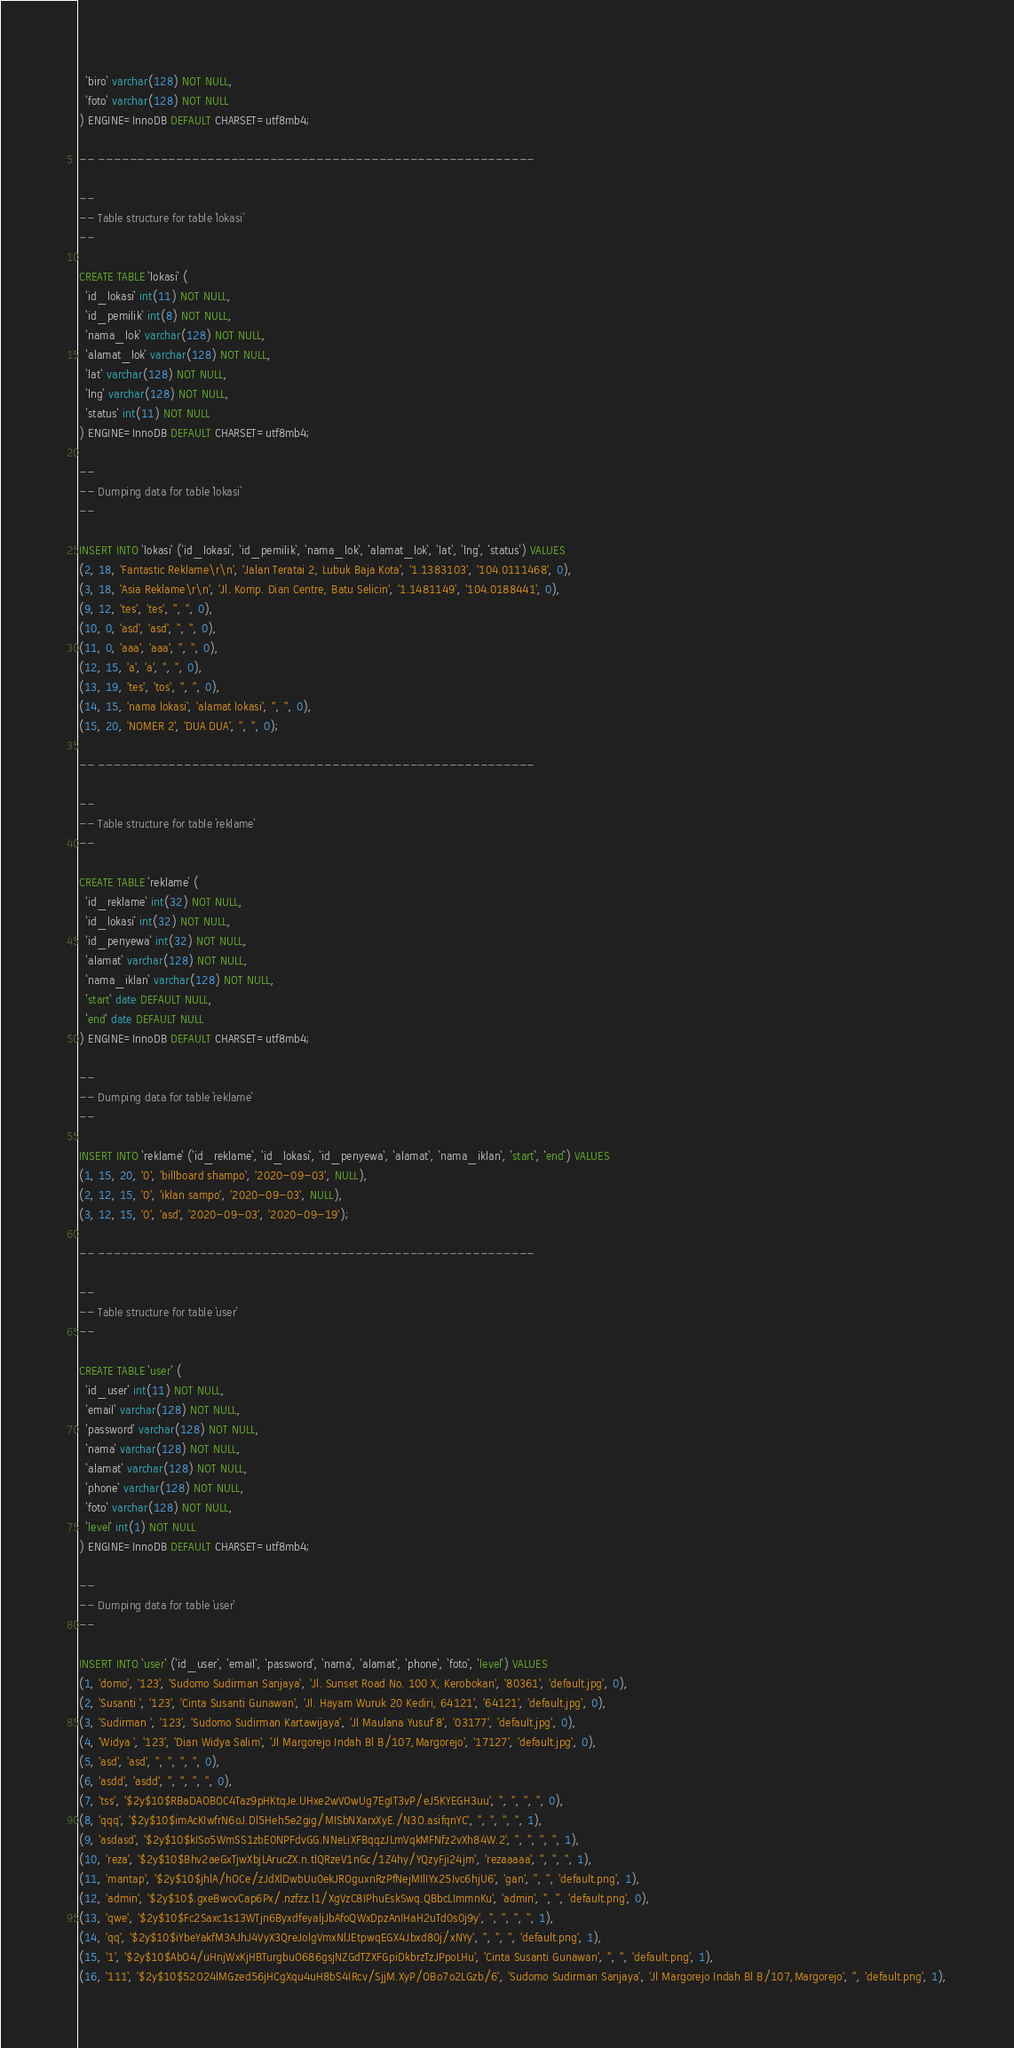<code> <loc_0><loc_0><loc_500><loc_500><_SQL_>  `biro` varchar(128) NOT NULL,
  `foto` varchar(128) NOT NULL
) ENGINE=InnoDB DEFAULT CHARSET=utf8mb4;

-- --------------------------------------------------------

--
-- Table structure for table `lokasi`
--

CREATE TABLE `lokasi` (
  `id_lokasi` int(11) NOT NULL,
  `id_pemilik` int(8) NOT NULL,
  `nama_lok` varchar(128) NOT NULL,
  `alamat_lok` varchar(128) NOT NULL,
  `lat` varchar(128) NOT NULL,
  `lng` varchar(128) NOT NULL,
  `status` int(11) NOT NULL
) ENGINE=InnoDB DEFAULT CHARSET=utf8mb4;

--
-- Dumping data for table `lokasi`
--

INSERT INTO `lokasi` (`id_lokasi`, `id_pemilik`, `nama_lok`, `alamat_lok`, `lat`, `lng`, `status`) VALUES
(2, 18, 'Fantastic Reklame\r\n', 'Jalan Teratai 2, Lubuk Baja Kota', '1.1383103', '104.0111468', 0),
(3, 18, 'Asia Reklame\r\n', 'Jl. Komp. Dian Centre, Batu Selicin', '1.1481149', '104.0188441', 0),
(9, 12, 'tes', 'tes', '', '', 0),
(10, 0, 'asd', 'asd', '', '', 0),
(11, 0, 'aaa', 'aaa', '', '', 0),
(12, 15, 'a', 'a', '', '', 0),
(13, 19, 'tes', 'tos', '', '', 0),
(14, 15, 'nama lokasi', 'alamat lokasi', '', '', 0),
(15, 20, 'NOMER 2', 'DUA DUA', '', '', 0);

-- --------------------------------------------------------

--
-- Table structure for table `reklame`
--

CREATE TABLE `reklame` (
  `id_reklame` int(32) NOT NULL,
  `id_lokasi` int(32) NOT NULL,
  `id_penyewa` int(32) NOT NULL,
  `alamat` varchar(128) NOT NULL,
  `nama_iklan` varchar(128) NOT NULL,
  `start` date DEFAULT NULL,
  `end` date DEFAULT NULL
) ENGINE=InnoDB DEFAULT CHARSET=utf8mb4;

--
-- Dumping data for table `reklame`
--

INSERT INTO `reklame` (`id_reklame`, `id_lokasi`, `id_penyewa`, `alamat`, `nama_iklan`, `start`, `end`) VALUES
(1, 15, 20, '0', 'billboard shampo', '2020-09-03', NULL),
(2, 12, 15, '0', 'iklan sampo', '2020-09-03', NULL),
(3, 12, 15, '0', 'asd', '2020-09-03', '2020-09-19');

-- --------------------------------------------------------

--
-- Table structure for table `user`
--

CREATE TABLE `user` (
  `id_user` int(11) NOT NULL,
  `email` varchar(128) NOT NULL,
  `password` varchar(128) NOT NULL,
  `nama` varchar(128) NOT NULL,
  `alamat` varchar(128) NOT NULL,
  `phone` varchar(128) NOT NULL,
  `foto` varchar(128) NOT NULL,
  `level` int(1) NOT NULL
) ENGINE=InnoDB DEFAULT CHARSET=utf8mb4;

--
-- Dumping data for table `user`
--

INSERT INTO `user` (`id_user`, `email`, `password`, `nama`, `alamat`, `phone`, `foto`, `level`) VALUES
(1, 'domo', '123', 'Sudomo Sudirman Sanjaya', 'Jl. Sunset Road No. 100 X, Kerobokan', '80361', 'default.jpg', 0),
(2, 'Susanti ', '123', 'Cinta Susanti Gunawan', 'Jl. Hayam Wuruk 20 Kediri, 64121', '64121', 'default.jpg', 0),
(3, 'Sudirman ', '123', 'Sudomo Sudirman Kartawijaya', 'Jl Maulana Yusuf 8', '03177', 'default.jpg', 0),
(4, 'Widya ', '123', 'Dian Widya Salim', 'Jl Margorejo Indah Bl B/107,Margorejo', '17127', 'default.jpg', 0),
(5, 'asd', 'asd', '', '', '', '', 0),
(6, 'asdd', 'asdd', '', '', '', '', 0),
(7, 'tss', '$2y$10$RBaDAOBOC4Taz9pHKtqJe.UHxe2wVOwUg7EgIT3vP/eJ5KYEGH3uu', '', '', '', '', 0),
(8, 'qqq', '$2y$10$imAcKIwfrN6oJ.Dl5Heh5e2gig/MISbNXarxXyE./N3O.asifqnYC', '', '', '', '', 1),
(9, 'asdasd', '$2y$10$kISo5WmSS1zbE0NPFdvGG.NNeLiXFBqqzJLmVqkMFNfz2vXh84W.2', '', '', '', '', 1),
(10, 'reza', '$2y$10$Bhv2aeGxTjwXbjLArucZX.n.tlQRzeV1nGc/1Z4hy/YQzyFji24jm', 'rezaaaaa', '', '', '', 1),
(11, 'mantap', '$2y$10$jhlA/hOCe/zJdXlDwbUu0ekJROguxnRzPfNejMIlIYx25Ivc6hjU6', 'gan', '', '', 'default.png', 1),
(12, 'admin', '$2y$10$.gxeBwcvCap6Px/.nzfzz.l1/XgVzC8IPhuEskSwq.QBbcLImmnKu', 'admin', '', '', 'default.png', 0),
(13, 'qwe', '$2y$10$Fc2Saxc1s13WTjn6ByxdfeyaljJbAfoQWxDpzAnIHaH2uTd0s0j9y', '', '', '', '', 1),
(14, 'qq', '$2y$10$iYbeYakfM3AJhJ4VyX3QreJolgVmxNlJEtpwqEGX4Jbxd80j/xNYy', '', '', '', 'default.png', 1),
(15, '1', '$2y$10$AbO4/uHnjWxKjHBTurgbuO686gsjNZGdTZXFGpiDkbrzTzJPpoLHu', 'Cinta Susanti Gunawan', '', '', 'default.png', 1),
(16, '111', '$2y$10$52O24lMGzed56jHCgXqu4uH8bS4IRcv/SjjM.XyP/OBo7o2LGzb/6', 'Sudomo Sudirman Sanjaya', 'Jl Margorejo Indah Bl B/107,Margorejo', '', 'default.png', 1),</code> 